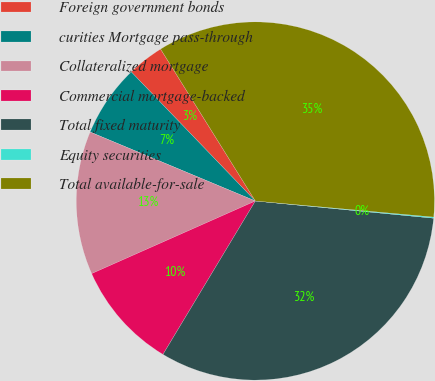Convert chart to OTSL. <chart><loc_0><loc_0><loc_500><loc_500><pie_chart><fcel>Foreign government bonds<fcel>curities Mortgage pass-through<fcel>Collateralized mortgage<fcel>Commercial mortgage-backed<fcel>Total fixed maturity<fcel>Equity securities<fcel>Total available-for-sale<nl><fcel>3.31%<fcel>6.52%<fcel>12.94%<fcel>9.73%<fcel>32.1%<fcel>0.1%<fcel>35.31%<nl></chart> 